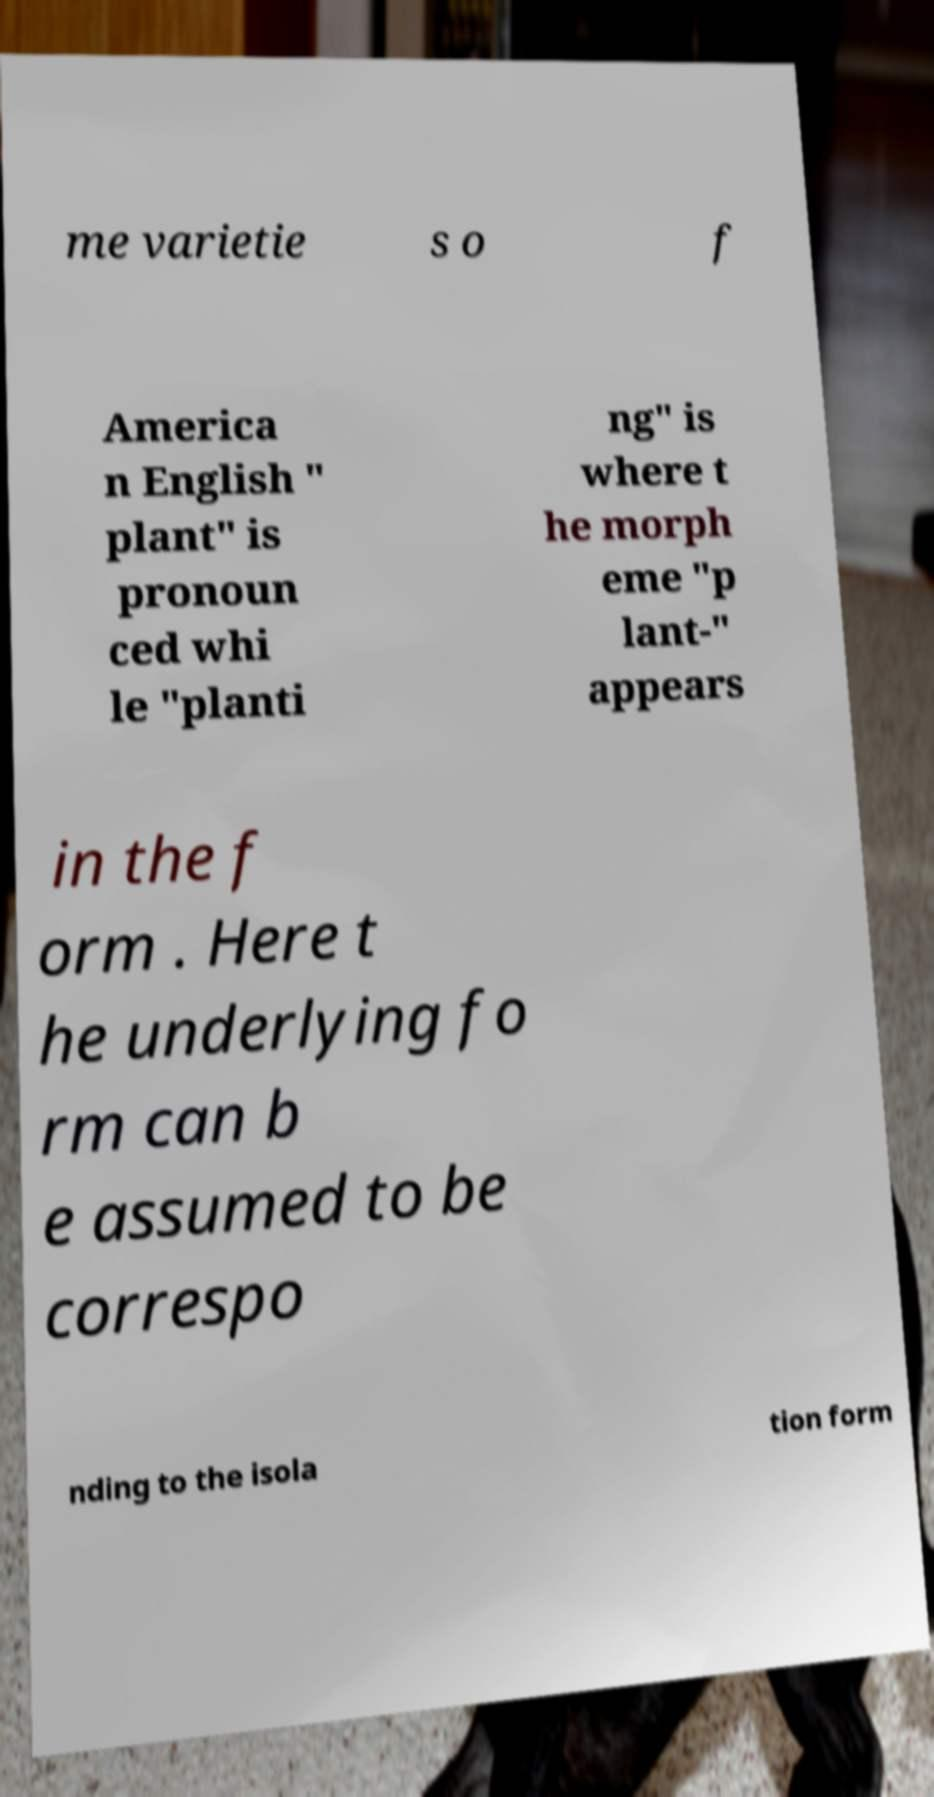Could you assist in decoding the text presented in this image and type it out clearly? me varietie s o f America n English " plant" is pronoun ced whi le "planti ng" is where t he morph eme "p lant-" appears in the f orm . Here t he underlying fo rm can b e assumed to be correspo nding to the isola tion form 